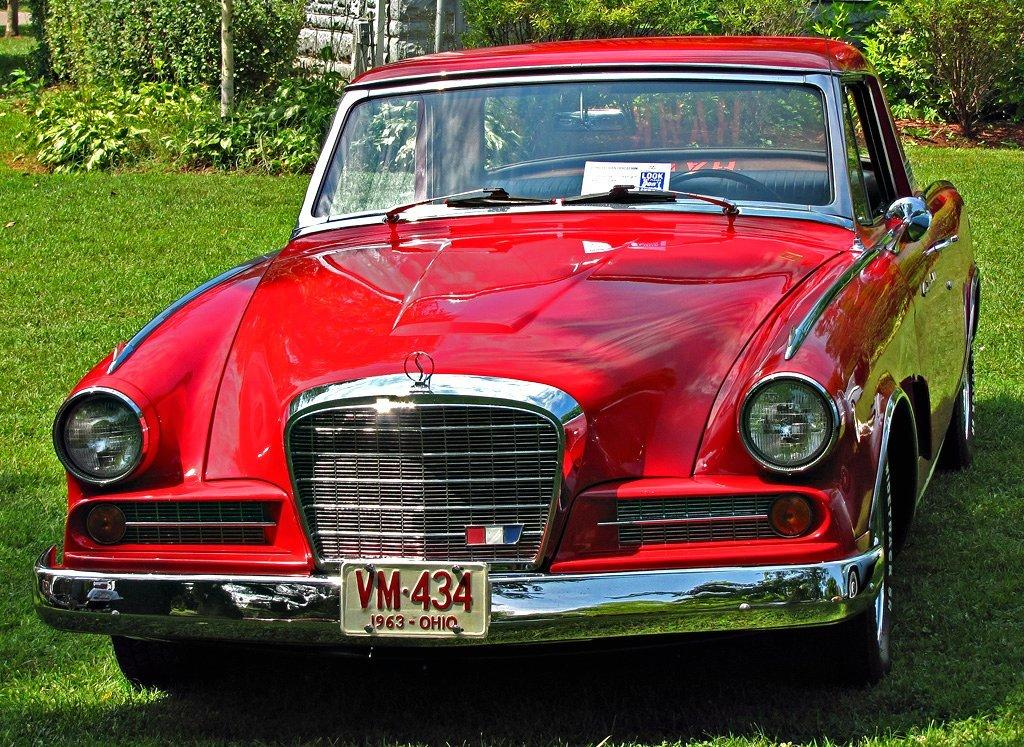What color is the car in the image? The car in the image is red. Where is the car located in the image? The car is on the ground in the image. What can be seen in the background of the image? Plants, trees, and grass are visible in the background of the image. Can you hear the thunder in the image? There is no mention of thunder or any sound in the image, so it cannot be heard. 